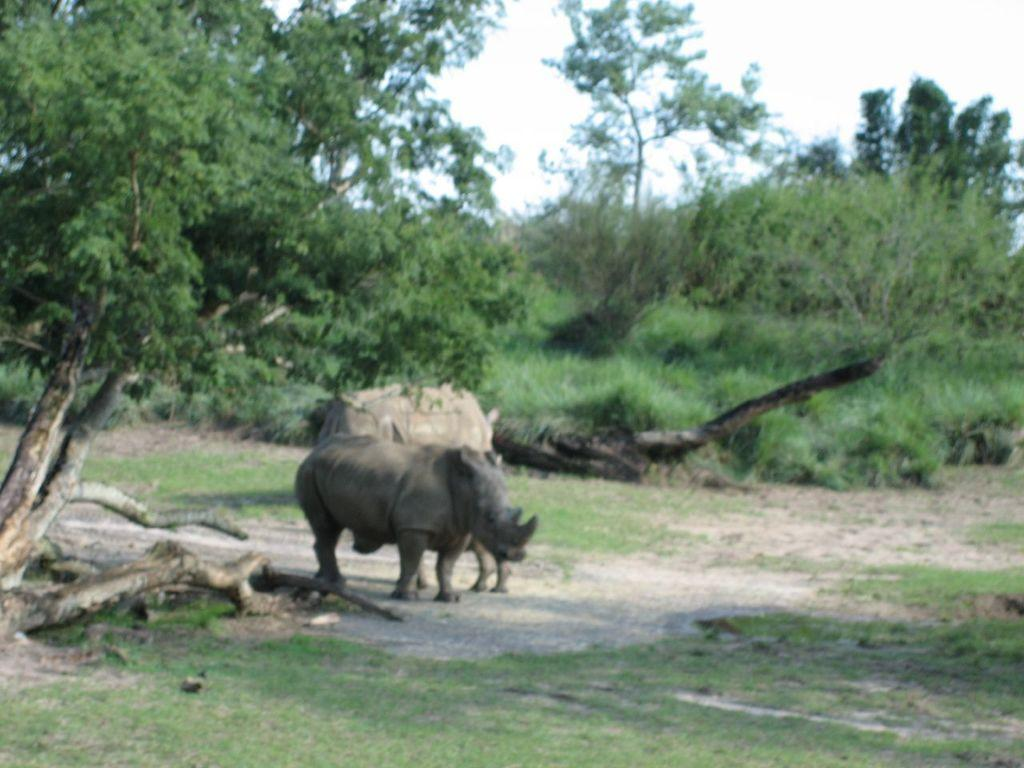What animals are in the picture? There are rhinoceros in the picture. What are the rhinoceros doing in the picture? The rhinoceros are standing. What type of vegetation is around the rhinoceros? There is grass around the rhinoceros. What can be seen in the background of the picture? There are trees in the picture. What is the condition of the sky in the picture? The sky is clear in the picture. What type of coat is the rhinoceros wearing to the party in the image? There is no coat or party present in the image; the rhinoceros are standing in a natural environment. What type of work are the rhinoceros doing in the image? There is no indication of work being done in the image; the rhinoceros are simply standing. 